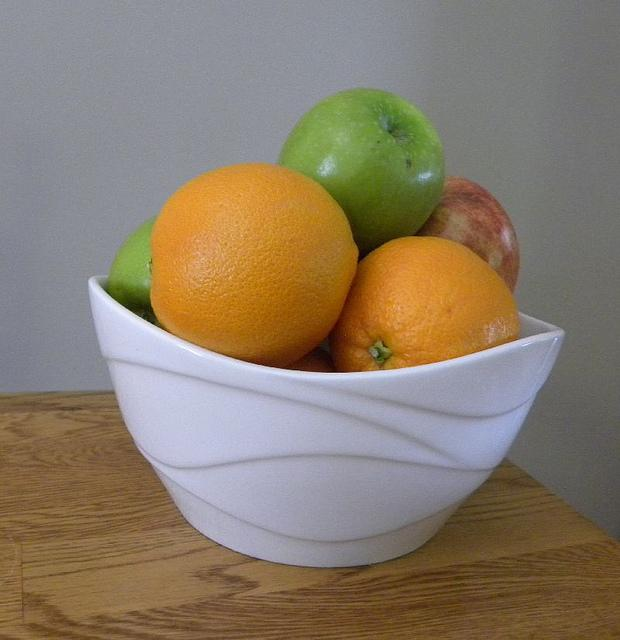What color skin does the tartest fruit seen here have?

Choices:
A) green
B) yellow
C) orange
D) red green 